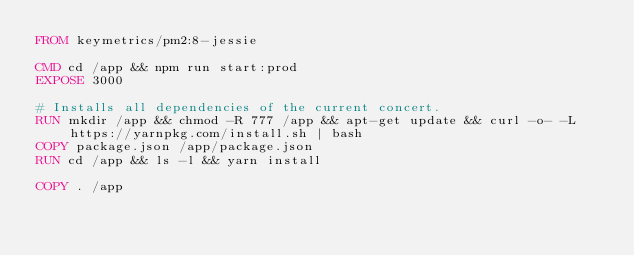<code> <loc_0><loc_0><loc_500><loc_500><_Dockerfile_>FROM keymetrics/pm2:8-jessie

CMD cd /app && npm run start:prod
EXPOSE 3000

# Installs all dependencies of the current concert.
RUN mkdir /app && chmod -R 777 /app && apt-get update && curl -o- -L https://yarnpkg.com/install.sh | bash
COPY package.json /app/package.json
RUN cd /app && ls -l && yarn install

COPY . /app</code> 